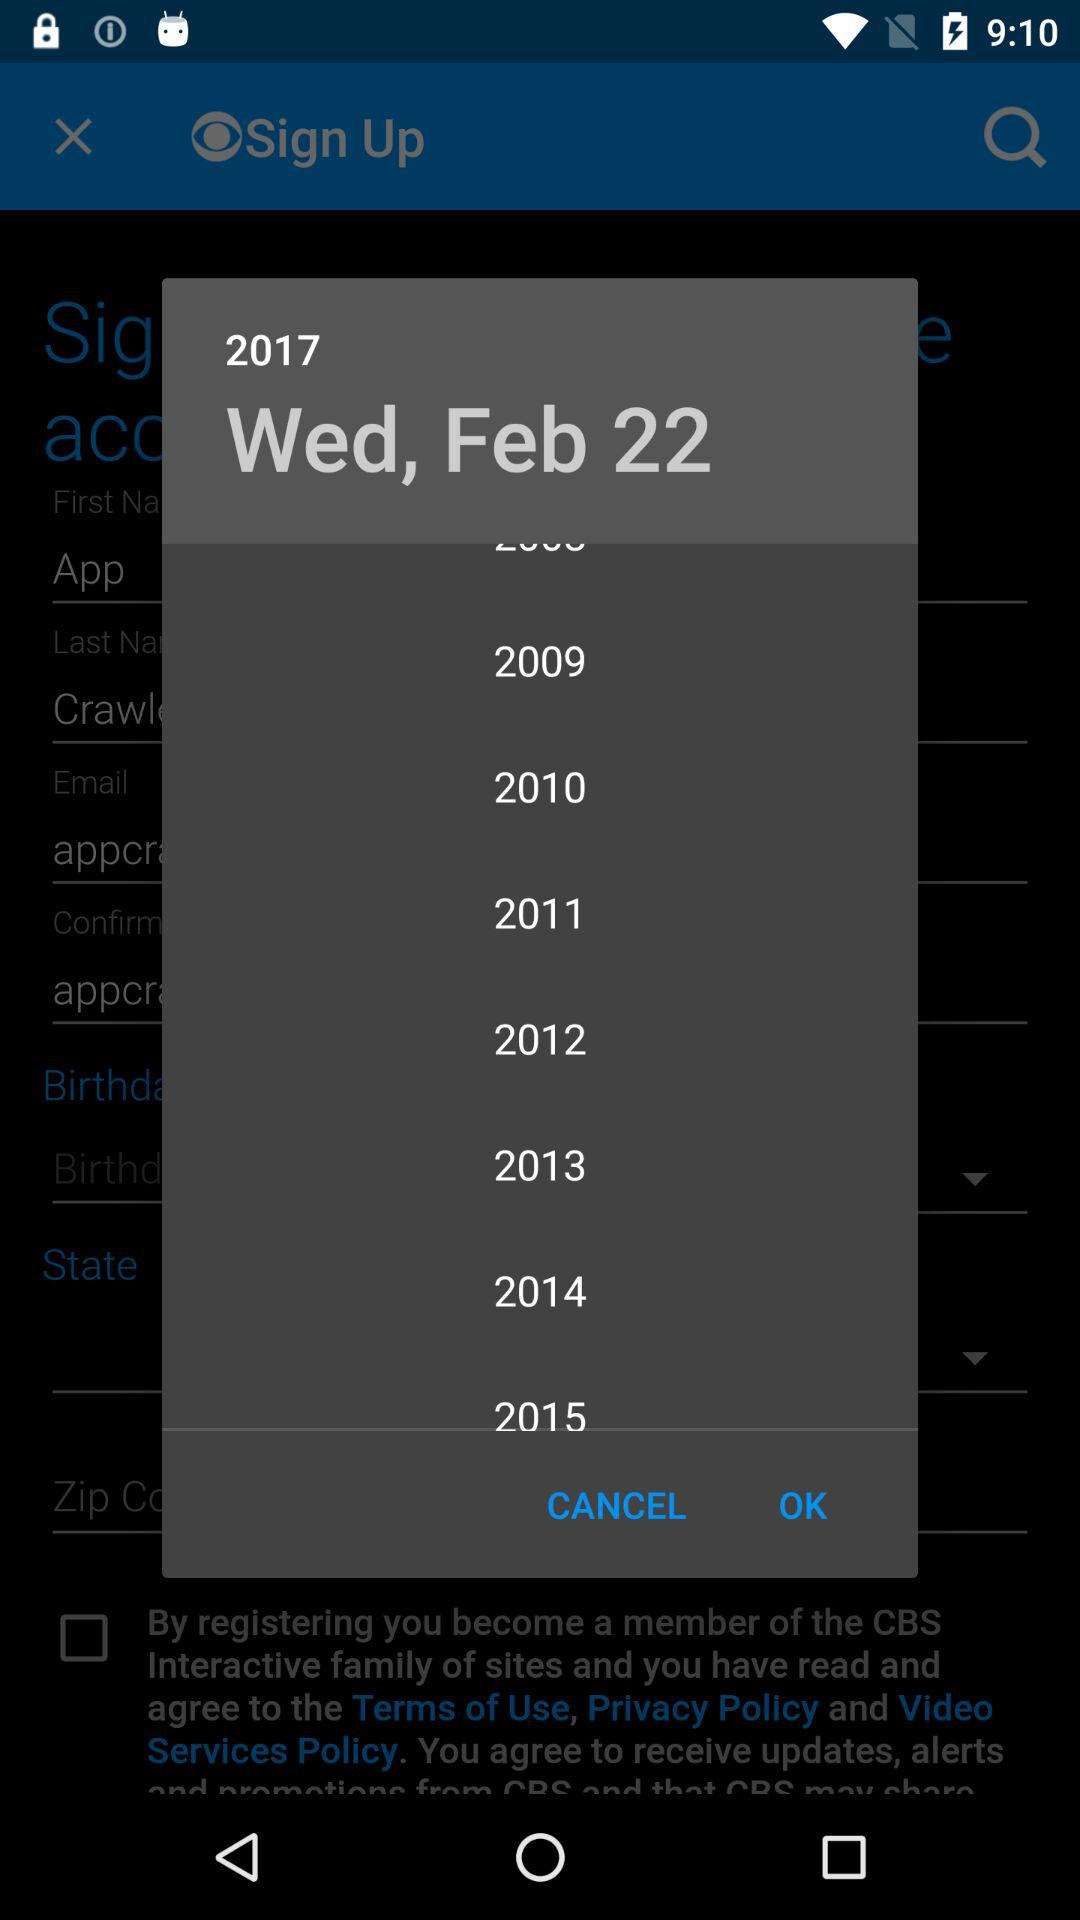What is the zip code?
When the provided information is insufficient, respond with <no answer>. <no answer> 